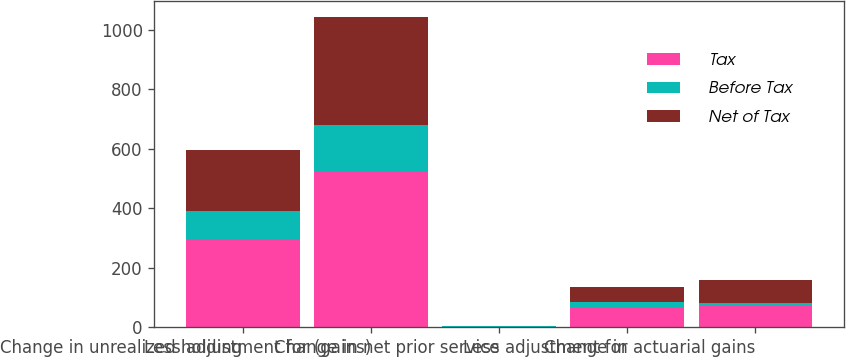<chart> <loc_0><loc_0><loc_500><loc_500><stacked_bar_chart><ecel><fcel>Change in unrealized holding<fcel>Less adjustment for (gains)<fcel>Change in net prior service<fcel>Less adjustment for<fcel>Change in actuarial gains<nl><fcel>Tax<fcel>298<fcel>522<fcel>2<fcel>67<fcel>73<nl><fcel>Before Tax<fcel>93<fcel>160<fcel>1<fcel>19<fcel>7<nl><fcel>Net of Tax<fcel>205<fcel>362<fcel>1<fcel>48<fcel>80<nl></chart> 